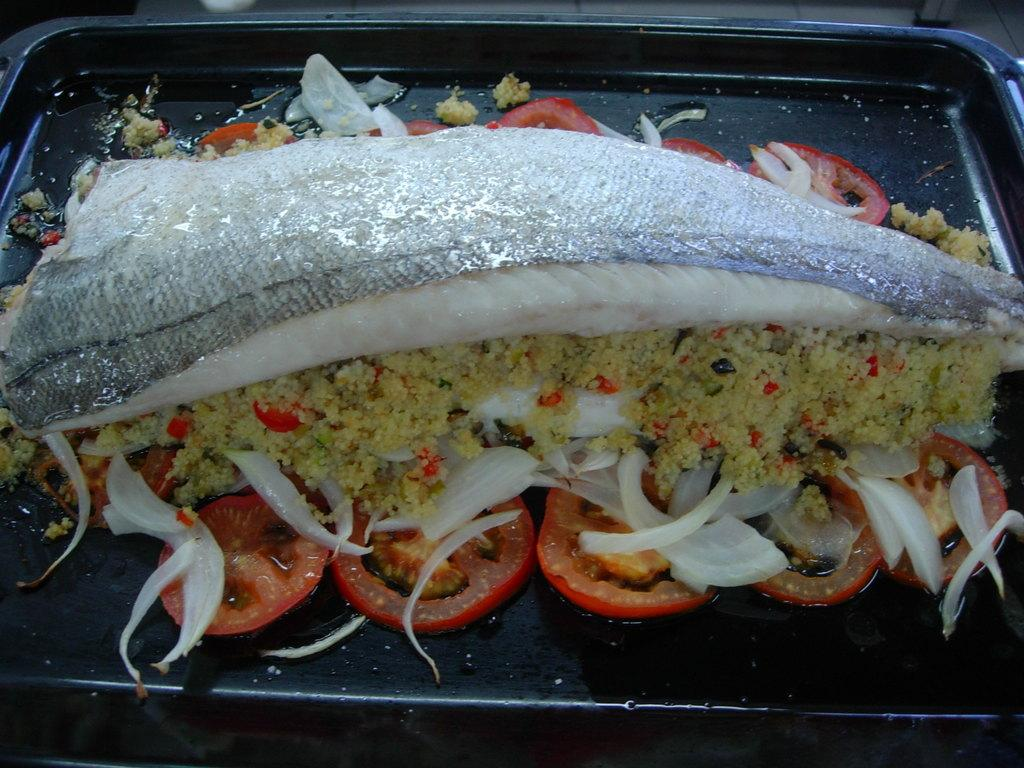What is the main subject of the image? The main subject of the image is a food dish. What type of food can be seen in the dish? The food dish contains silver color fish, tomatoes, and onions. What is the color of the fish in the dish? The fish in the dish are silver in color. How is the food dish presented in the image? The food dish is placed on a black tray. How many bricks are used to build the wall behind the food dish in the image? There is no wall or bricks visible in the image; it only features a food dish with silver color fish, tomatoes, and onions placed on a black tray. 